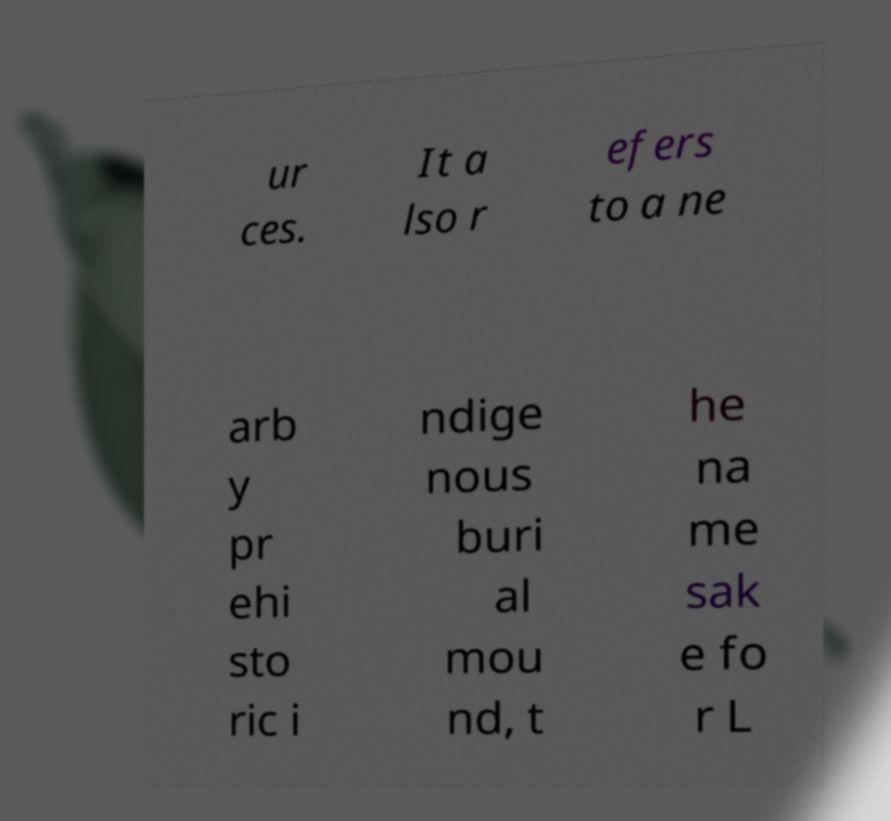Please read and relay the text visible in this image. What does it say? ur ces. It a lso r efers to a ne arb y pr ehi sto ric i ndige nous buri al mou nd, t he na me sak e fo r L 